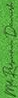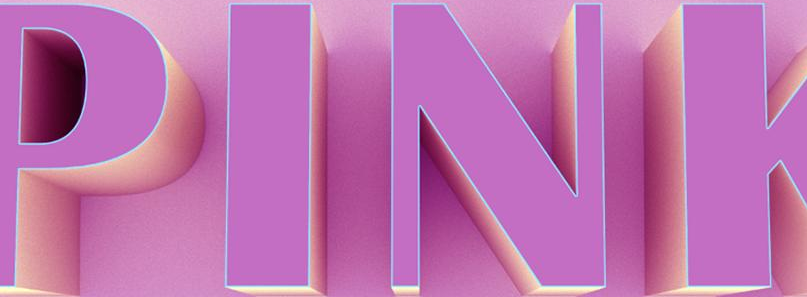Identify the words shown in these images in order, separated by a semicolon. #; PINK 